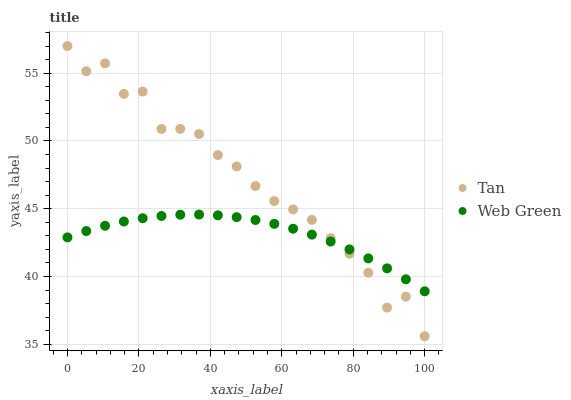Does Web Green have the minimum area under the curve?
Answer yes or no. Yes. Does Tan have the maximum area under the curve?
Answer yes or no. Yes. Does Web Green have the maximum area under the curve?
Answer yes or no. No. Is Web Green the smoothest?
Answer yes or no. Yes. Is Tan the roughest?
Answer yes or no. Yes. Is Web Green the roughest?
Answer yes or no. No. Does Tan have the lowest value?
Answer yes or no. Yes. Does Web Green have the lowest value?
Answer yes or no. No. Does Tan have the highest value?
Answer yes or no. Yes. Does Web Green have the highest value?
Answer yes or no. No. Does Web Green intersect Tan?
Answer yes or no. Yes. Is Web Green less than Tan?
Answer yes or no. No. Is Web Green greater than Tan?
Answer yes or no. No. 